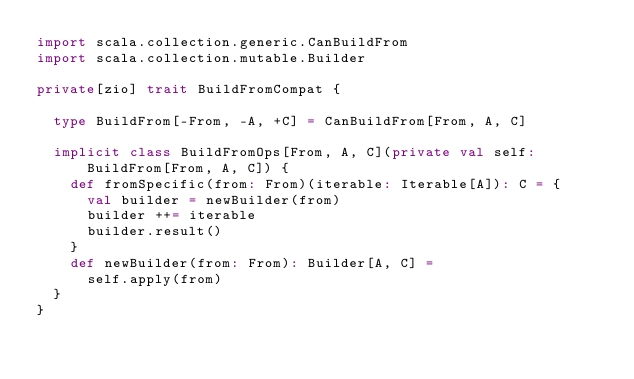<code> <loc_0><loc_0><loc_500><loc_500><_Scala_>import scala.collection.generic.CanBuildFrom
import scala.collection.mutable.Builder

private[zio] trait BuildFromCompat {

  type BuildFrom[-From, -A, +C] = CanBuildFrom[From, A, C]

  implicit class BuildFromOps[From, A, C](private val self: BuildFrom[From, A, C]) {
    def fromSpecific(from: From)(iterable: Iterable[A]): C = {
      val builder = newBuilder(from)
      builder ++= iterable
      builder.result()
    }
    def newBuilder(from: From): Builder[A, C] =
      self.apply(from)
  }
}
</code> 